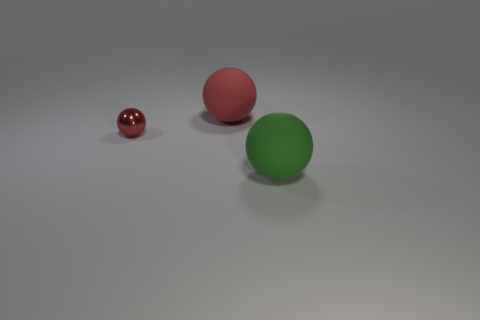Subtract all blue cubes. How many red balls are left? 2 Add 3 large green matte spheres. How many objects exist? 6 Add 2 big green rubber balls. How many big green rubber balls exist? 3 Subtract 0 green cubes. How many objects are left? 3 Subtract all gray metal blocks. Subtract all green matte things. How many objects are left? 2 Add 2 green matte spheres. How many green matte spheres are left? 3 